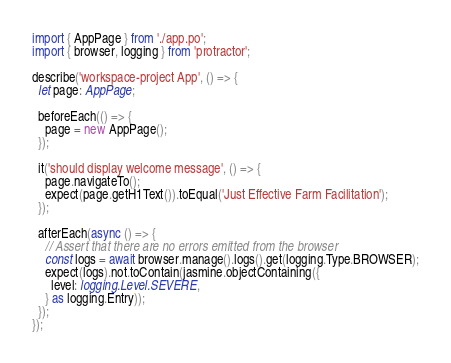Convert code to text. <code><loc_0><loc_0><loc_500><loc_500><_TypeScript_>import { AppPage } from './app.po';
import { browser, logging } from 'protractor';

describe('workspace-project App', () => {
  let page: AppPage;

  beforeEach(() => {
    page = new AppPage();
  });

  it('should display welcome message', () => {
    page.navigateTo();
    expect(page.getH1Text()).toEqual('Just Effective Farm Facilitation');
  });

  afterEach(async () => {
    // Assert that there are no errors emitted from the browser
    const logs = await browser.manage().logs().get(logging.Type.BROWSER);
    expect(logs).not.toContain(jasmine.objectContaining({
      level: logging.Level.SEVERE,
    } as logging.Entry));
  });
});
</code> 